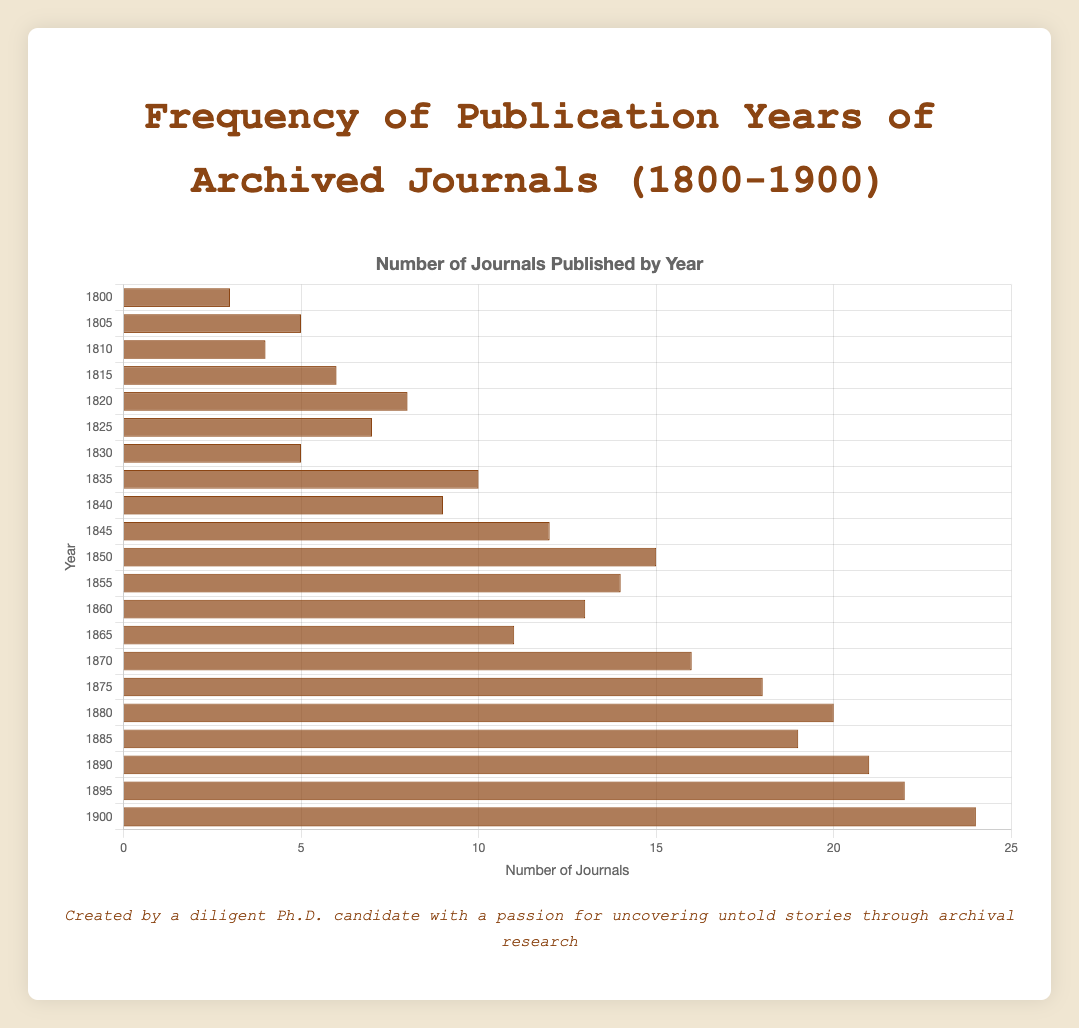Which year had the highest number of archived journals published? To find the year with the highest number of archived journals published, look for the bar with the greatest length in the horizontal bar chart. According to the chart, the year 1900 had the highest number of archived journals published, totaling 24 journals.
Answer: 1900 What is the difference in the number of journals published between the years 1850 and 1860? First, find the number of journals published in each of the years 1850 and 1860 from the chart. The year 1850 had 15 journals, and the year 1860 had 13 journals. Subtract the smaller number from the larger one to get the difference: 15 - 13 = 2.
Answer: 2 Which year has more archived journals published: 1825 or 1865? From the chart, observe the number of journals published in 1825 and 1865. The year 1825 had 7 journals, while the year 1865 had 11 journals. Since 11 is greater than 7, the year 1865 had more archived journals published.
Answer: 1865 What is the average number of journals published in the years 1880, 1885, and 1890? To calculate the average, first find the number of journals published in each of these years from the chart: 1880 had 20 journals, 1885 had 19 journals, and 1890 had 21 journals. Sum these values: 20 + 19 + 21 = 60. Then divide by the number of years to find the average: 60 / 3 = 20.
Answer: 20 How many years had exactly 10 or more journals published? Count the number of bars representing years with 10 or more journals. From the chart, the years 1835, 1845, 1850, 1855, 1860, 1865, 1870, 1875, 1880, 1885, 1890, 1895, and 1900 all have 10 or more journals. This totals 13 years.
Answer: 13 What is the sum of the journals published in the years 1800, 1805, and 1810? Find the number of journals for each year (1800: 3 journals, 1805: 5 journals, 1810: 4 journals). Add them together to get the sum: 3 + 5 + 4 = 12.
Answer: 12 Which year had fewer journals published: 1840 or 1855? From the chart, observe the number of journals for each year: 1840 had 9 journals, and 1855 had 14 journals. Since 9 is less than 14, the year 1840 had fewer journals published.
Answer: 1840 